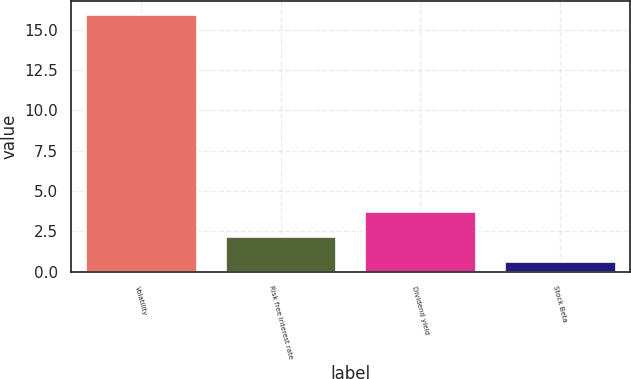<chart> <loc_0><loc_0><loc_500><loc_500><bar_chart><fcel>Volatility<fcel>Risk free interest rate<fcel>Dividend yield<fcel>Stock Beta<nl><fcel>16<fcel>2.21<fcel>3.74<fcel>0.68<nl></chart> 